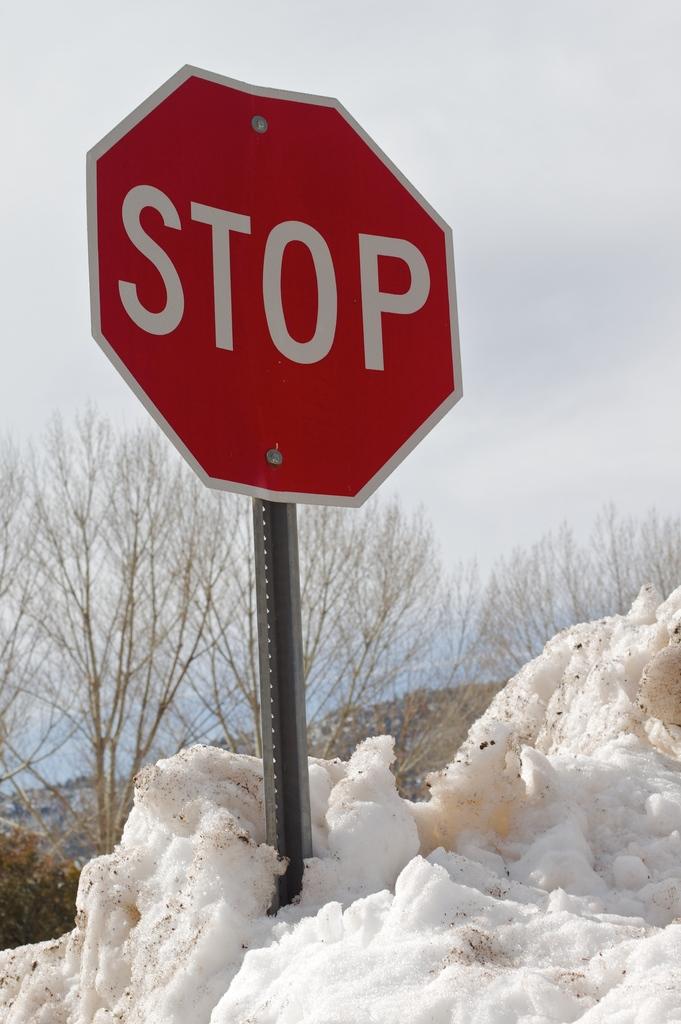What does the red sign say?
Your answer should be compact. Stop. 